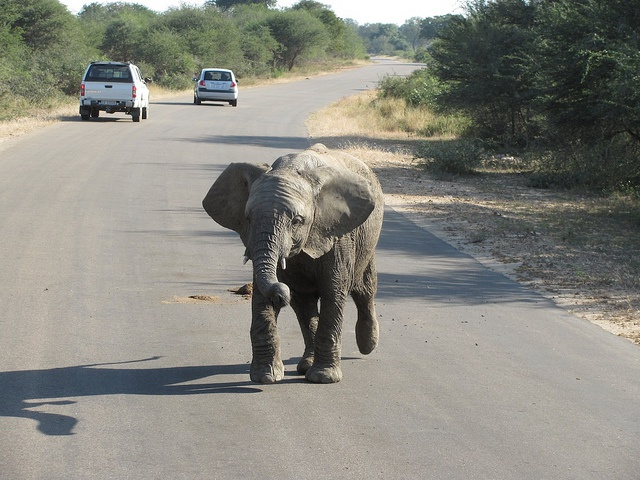Describe the objects in this image and their specific colors. I can see elephant in gray, black, and darkgray tones, car in gray, black, darkgray, and white tones, and car in gray, black, and darkgray tones in this image. 